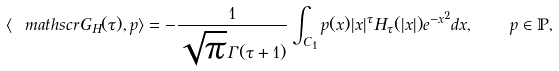Convert formula to latex. <formula><loc_0><loc_0><loc_500><loc_500>\langle \ m a t h s c r { G } _ { H } ( \tau ) , p \rangle = - \frac { 1 } { \sqrt { \pi } \Gamma ( \tau + 1 ) } \int _ { C _ { 1 } } p ( x ) | x | ^ { \tau } H _ { \tau } ( | x | ) e ^ { - x ^ { 2 } } d x , \quad p \in \mathbb { P } ,</formula> 